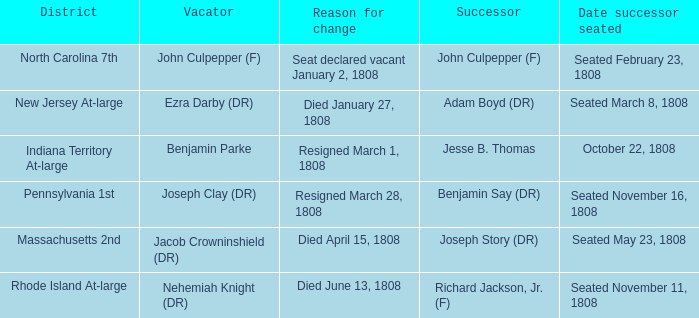When was the successor for the massachusetts 2nd district seated? Seated May 23, 1808. 